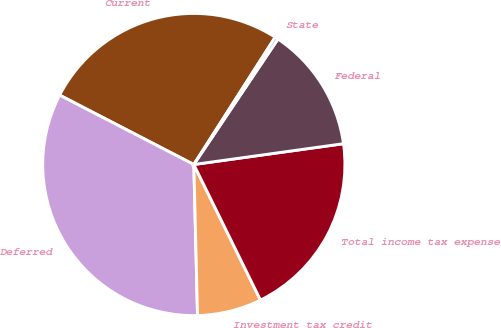<chart> <loc_0><loc_0><loc_500><loc_500><pie_chart><fcel>Current<fcel>Deferred<fcel>Investment tax credit<fcel>Total income tax expense<fcel>Federal<fcel>State<nl><fcel>26.46%<fcel>32.99%<fcel>6.88%<fcel>19.93%<fcel>13.4%<fcel>0.35%<nl></chart> 